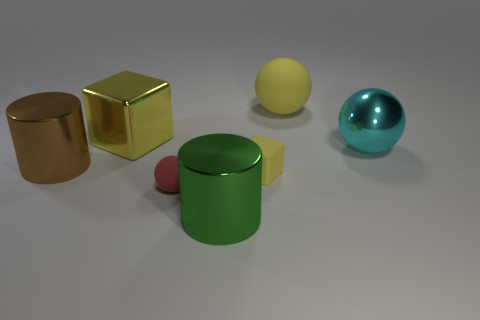Add 2 metal cylinders. How many objects exist? 9 Subtract all cylinders. How many objects are left? 5 Subtract 0 yellow cylinders. How many objects are left? 7 Subtract all big brown metallic cylinders. Subtract all yellow rubber things. How many objects are left? 4 Add 3 large cyan metal things. How many large cyan metal things are left? 4 Add 2 big red rubber things. How many big red rubber things exist? 2 